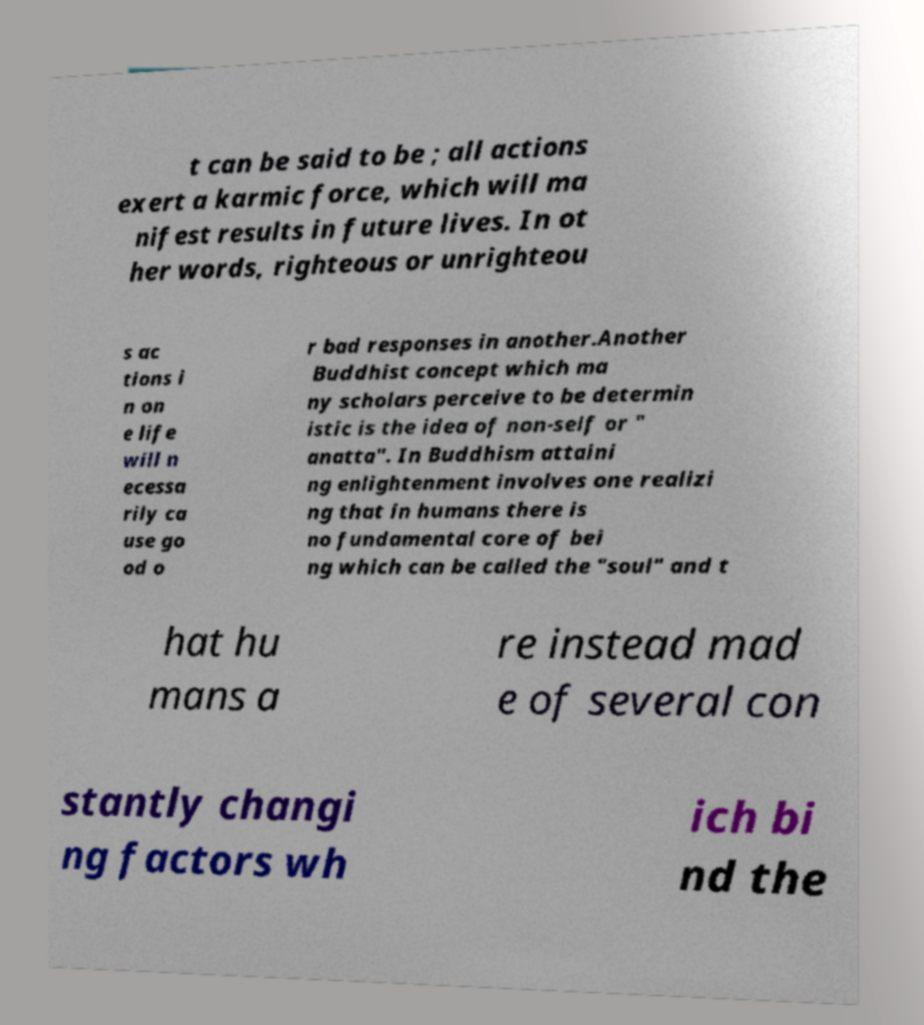I need the written content from this picture converted into text. Can you do that? t can be said to be ; all actions exert a karmic force, which will ma nifest results in future lives. In ot her words, righteous or unrighteou s ac tions i n on e life will n ecessa rily ca use go od o r bad responses in another.Another Buddhist concept which ma ny scholars perceive to be determin istic is the idea of non-self or " anatta". In Buddhism attaini ng enlightenment involves one realizi ng that in humans there is no fundamental core of bei ng which can be called the "soul" and t hat hu mans a re instead mad e of several con stantly changi ng factors wh ich bi nd the 